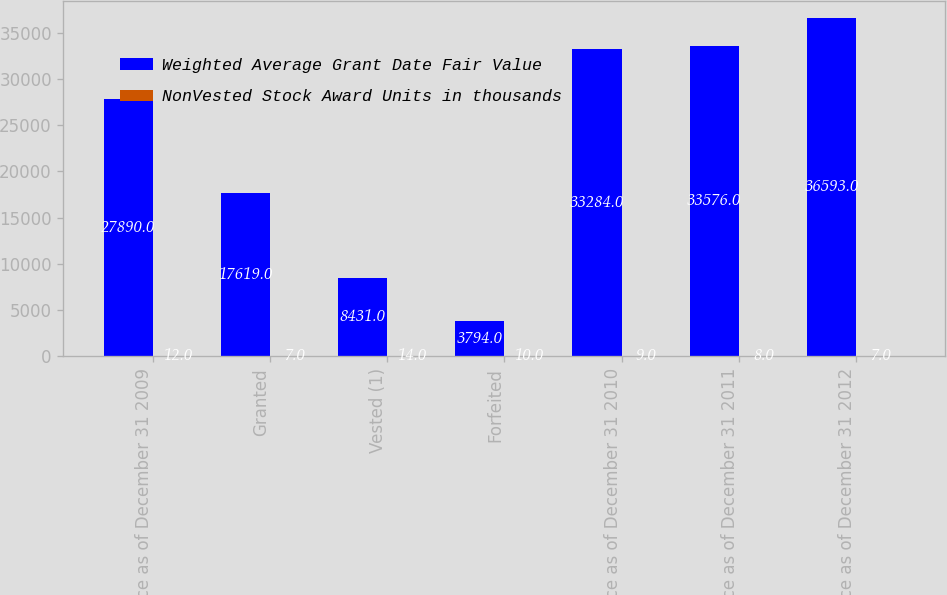Convert chart to OTSL. <chart><loc_0><loc_0><loc_500><loc_500><stacked_bar_chart><ecel><fcel>Balance as of December 31 2009<fcel>Granted<fcel>Vested (1)<fcel>Forfeited<fcel>Balance as of December 31 2010<fcel>Balance as of December 31 2011<fcel>Balance as of December 31 2012<nl><fcel>Weighted Average Grant Date Fair Value<fcel>27890<fcel>17619<fcel>8431<fcel>3794<fcel>33284<fcel>33576<fcel>36593<nl><fcel>NonVested Stock Award Units in thousands<fcel>12<fcel>7<fcel>14<fcel>10<fcel>9<fcel>8<fcel>7<nl></chart> 